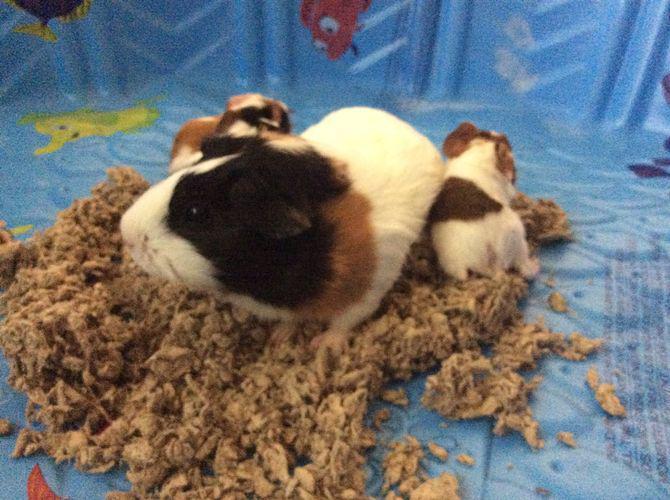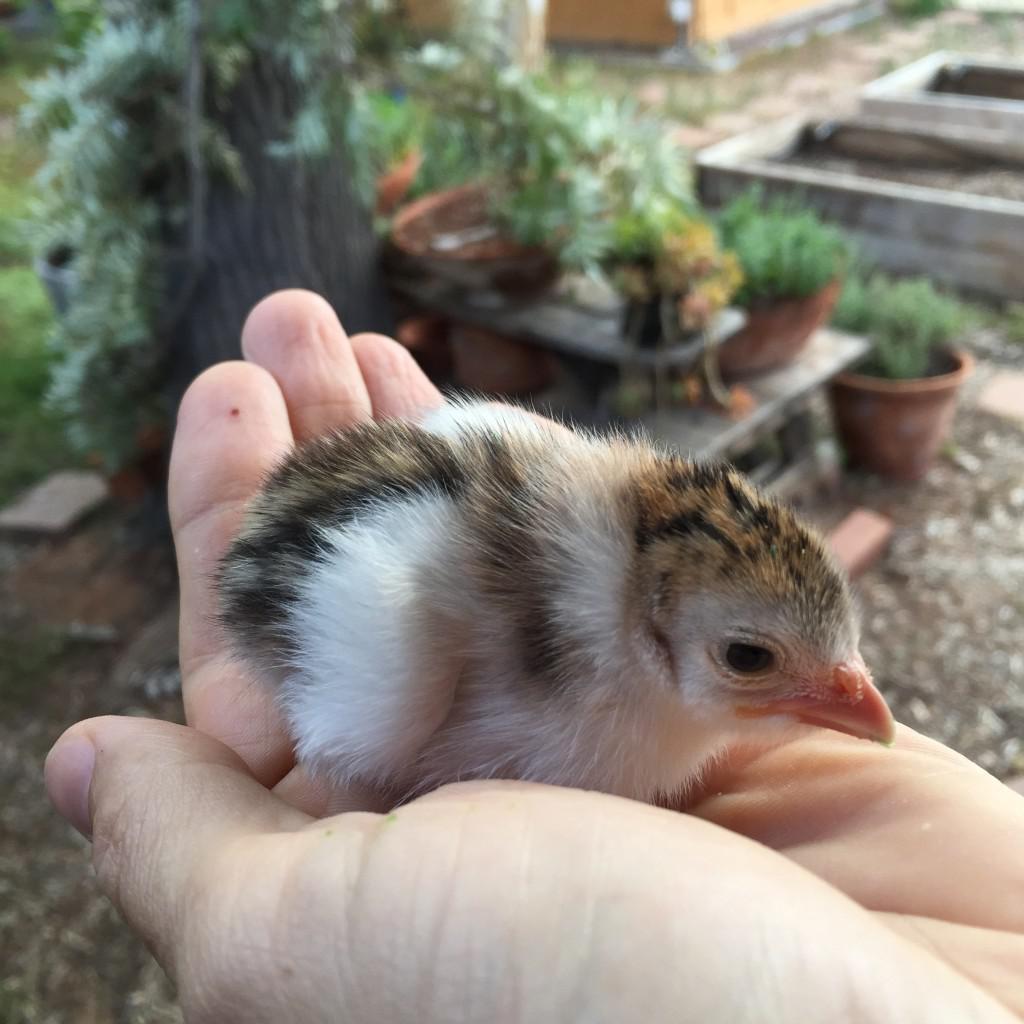The first image is the image on the left, the second image is the image on the right. Evaluate the accuracy of this statement regarding the images: "An image shows an extended hand holding at least one hamster.". Is it true? Answer yes or no. No. The first image is the image on the left, the second image is the image on the right. Evaluate the accuracy of this statement regarding the images: "In one image, at least one rodent is being held in a human hand". Is it true? Answer yes or no. No. 